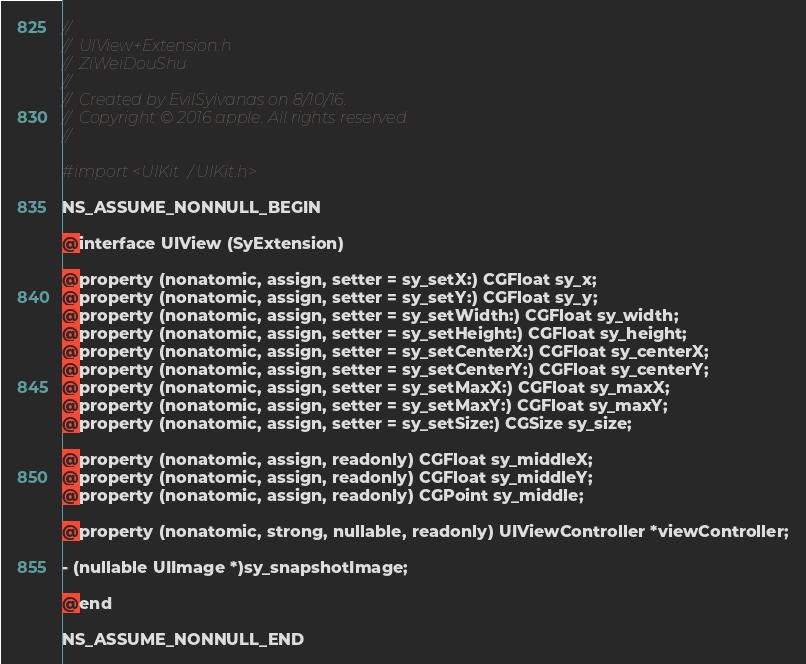Convert code to text. <code><loc_0><loc_0><loc_500><loc_500><_C_>//
//  UIView+Extension.h
//  ZiWeiDouShu
//
//  Created by EvilSylvanas on 8/10/16.
//  Copyright © 2016 apple. All rights reserved.
//

#import <UIKit/UIKit.h>

NS_ASSUME_NONNULL_BEGIN

@interface UIView (SyExtension)

@property (nonatomic, assign, setter = sy_setX:) CGFloat sy_x;
@property (nonatomic, assign, setter = sy_setY:) CGFloat sy_y;
@property (nonatomic, assign, setter = sy_setWidth:) CGFloat sy_width;
@property (nonatomic, assign, setter = sy_setHeight:) CGFloat sy_height;
@property (nonatomic, assign, setter = sy_setCenterX:) CGFloat sy_centerX;
@property (nonatomic, assign, setter = sy_setCenterY:) CGFloat sy_centerY;
@property (nonatomic, assign, setter = sy_setMaxX:) CGFloat sy_maxX;
@property (nonatomic, assign, setter = sy_setMaxY:) CGFloat sy_maxY;
@property (nonatomic, assign, setter = sy_setSize:) CGSize sy_size;

@property (nonatomic, assign, readonly) CGFloat sy_middleX;
@property (nonatomic, assign, readonly) CGFloat sy_middleY;
@property (nonatomic, assign, readonly) CGPoint sy_middle;

@property (nonatomic, strong, nullable, readonly) UIViewController *viewController;

- (nullable UIImage *)sy_snapshotImage;

@end

NS_ASSUME_NONNULL_END
</code> 